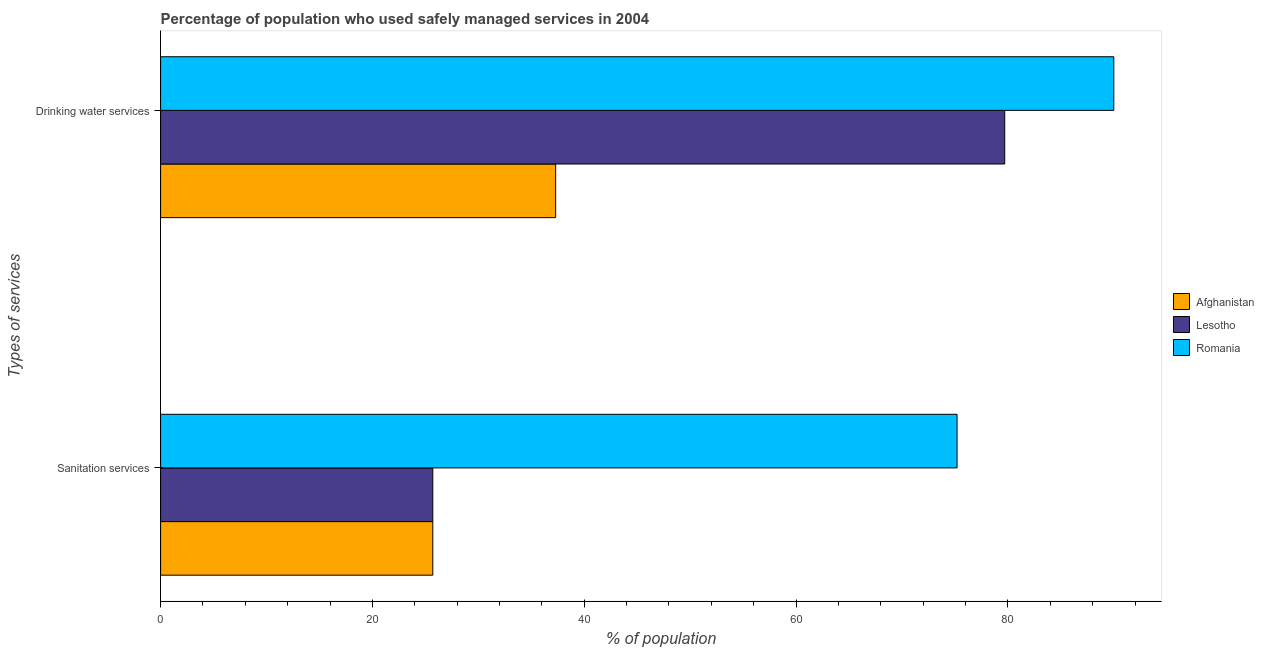How many different coloured bars are there?
Make the answer very short. 3. Are the number of bars per tick equal to the number of legend labels?
Offer a terse response. Yes. Are the number of bars on each tick of the Y-axis equal?
Provide a succinct answer. Yes. How many bars are there on the 1st tick from the top?
Provide a succinct answer. 3. What is the label of the 2nd group of bars from the top?
Your answer should be compact. Sanitation services. What is the percentage of population who used sanitation services in Romania?
Your response must be concise. 75.2. Across all countries, what is the minimum percentage of population who used sanitation services?
Offer a terse response. 25.7. In which country was the percentage of population who used sanitation services maximum?
Your answer should be compact. Romania. In which country was the percentage of population who used sanitation services minimum?
Give a very brief answer. Afghanistan. What is the total percentage of population who used sanitation services in the graph?
Offer a terse response. 126.6. What is the difference between the percentage of population who used sanitation services in Lesotho and that in Romania?
Offer a very short reply. -49.5. What is the difference between the percentage of population who used sanitation services in Romania and the percentage of population who used drinking water services in Afghanistan?
Provide a short and direct response. 37.9. What is the average percentage of population who used sanitation services per country?
Ensure brevity in your answer.  42.2. What is the difference between the percentage of population who used sanitation services and percentage of population who used drinking water services in Lesotho?
Your response must be concise. -54. What is the ratio of the percentage of population who used drinking water services in Romania to that in Lesotho?
Your response must be concise. 1.13. Is the percentage of population who used drinking water services in Romania less than that in Afghanistan?
Keep it short and to the point. No. What does the 1st bar from the top in Drinking water services represents?
Offer a terse response. Romania. What does the 1st bar from the bottom in Sanitation services represents?
Your response must be concise. Afghanistan. How many legend labels are there?
Offer a very short reply. 3. What is the title of the graph?
Offer a very short reply. Percentage of population who used safely managed services in 2004. What is the label or title of the X-axis?
Your response must be concise. % of population. What is the label or title of the Y-axis?
Offer a terse response. Types of services. What is the % of population of Afghanistan in Sanitation services?
Give a very brief answer. 25.7. What is the % of population of Lesotho in Sanitation services?
Give a very brief answer. 25.7. What is the % of population of Romania in Sanitation services?
Provide a short and direct response. 75.2. What is the % of population of Afghanistan in Drinking water services?
Provide a succinct answer. 37.3. What is the % of population in Lesotho in Drinking water services?
Give a very brief answer. 79.7. What is the % of population in Romania in Drinking water services?
Ensure brevity in your answer.  90. Across all Types of services, what is the maximum % of population in Afghanistan?
Offer a very short reply. 37.3. Across all Types of services, what is the maximum % of population in Lesotho?
Your answer should be compact. 79.7. Across all Types of services, what is the maximum % of population in Romania?
Your response must be concise. 90. Across all Types of services, what is the minimum % of population of Afghanistan?
Provide a succinct answer. 25.7. Across all Types of services, what is the minimum % of population in Lesotho?
Your answer should be very brief. 25.7. Across all Types of services, what is the minimum % of population of Romania?
Give a very brief answer. 75.2. What is the total % of population of Lesotho in the graph?
Your response must be concise. 105.4. What is the total % of population in Romania in the graph?
Give a very brief answer. 165.2. What is the difference between the % of population of Lesotho in Sanitation services and that in Drinking water services?
Make the answer very short. -54. What is the difference between the % of population of Romania in Sanitation services and that in Drinking water services?
Your answer should be very brief. -14.8. What is the difference between the % of population of Afghanistan in Sanitation services and the % of population of Lesotho in Drinking water services?
Provide a short and direct response. -54. What is the difference between the % of population in Afghanistan in Sanitation services and the % of population in Romania in Drinking water services?
Your answer should be very brief. -64.3. What is the difference between the % of population in Lesotho in Sanitation services and the % of population in Romania in Drinking water services?
Make the answer very short. -64.3. What is the average % of population in Afghanistan per Types of services?
Give a very brief answer. 31.5. What is the average % of population of Lesotho per Types of services?
Make the answer very short. 52.7. What is the average % of population in Romania per Types of services?
Provide a succinct answer. 82.6. What is the difference between the % of population in Afghanistan and % of population in Lesotho in Sanitation services?
Provide a short and direct response. 0. What is the difference between the % of population of Afghanistan and % of population of Romania in Sanitation services?
Your answer should be compact. -49.5. What is the difference between the % of population of Lesotho and % of population of Romania in Sanitation services?
Keep it short and to the point. -49.5. What is the difference between the % of population in Afghanistan and % of population in Lesotho in Drinking water services?
Offer a terse response. -42.4. What is the difference between the % of population in Afghanistan and % of population in Romania in Drinking water services?
Ensure brevity in your answer.  -52.7. What is the ratio of the % of population of Afghanistan in Sanitation services to that in Drinking water services?
Your response must be concise. 0.69. What is the ratio of the % of population of Lesotho in Sanitation services to that in Drinking water services?
Make the answer very short. 0.32. What is the ratio of the % of population in Romania in Sanitation services to that in Drinking water services?
Your answer should be compact. 0.84. What is the difference between the highest and the second highest % of population of Lesotho?
Offer a very short reply. 54. What is the difference between the highest and the second highest % of population of Romania?
Provide a short and direct response. 14.8. What is the difference between the highest and the lowest % of population of Afghanistan?
Ensure brevity in your answer.  11.6. What is the difference between the highest and the lowest % of population in Lesotho?
Make the answer very short. 54. 